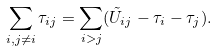<formula> <loc_0><loc_0><loc_500><loc_500>\sum _ { i , j \neq i } \tau _ { i j } = \sum _ { i > j } ( \tilde { U } _ { i j } - \tau _ { i } - \tau _ { j } ) .</formula> 